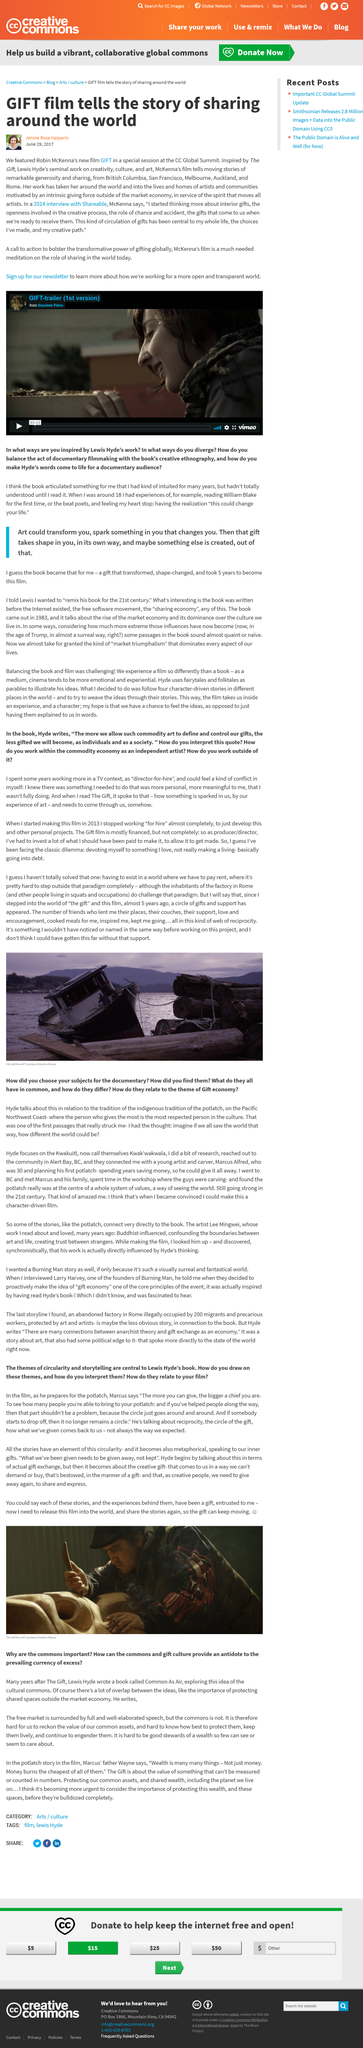Specify some key components in this picture. The city depicted in Robin McKenna's film "GIFT" is Melbourne, in Australia. What is it that has propelled him to this point? The answer lies in the support he has received. Since stepping into the world of "the gift," a circle of gifts and support has appeared for me. Since Robin McKenna's interview with Shareable and the screening of his film GIFT at the CC Global Summit, three years have passed. The inspiration for Robin McKenna's film 'GIFT' was the concept of 'The Gift'. 